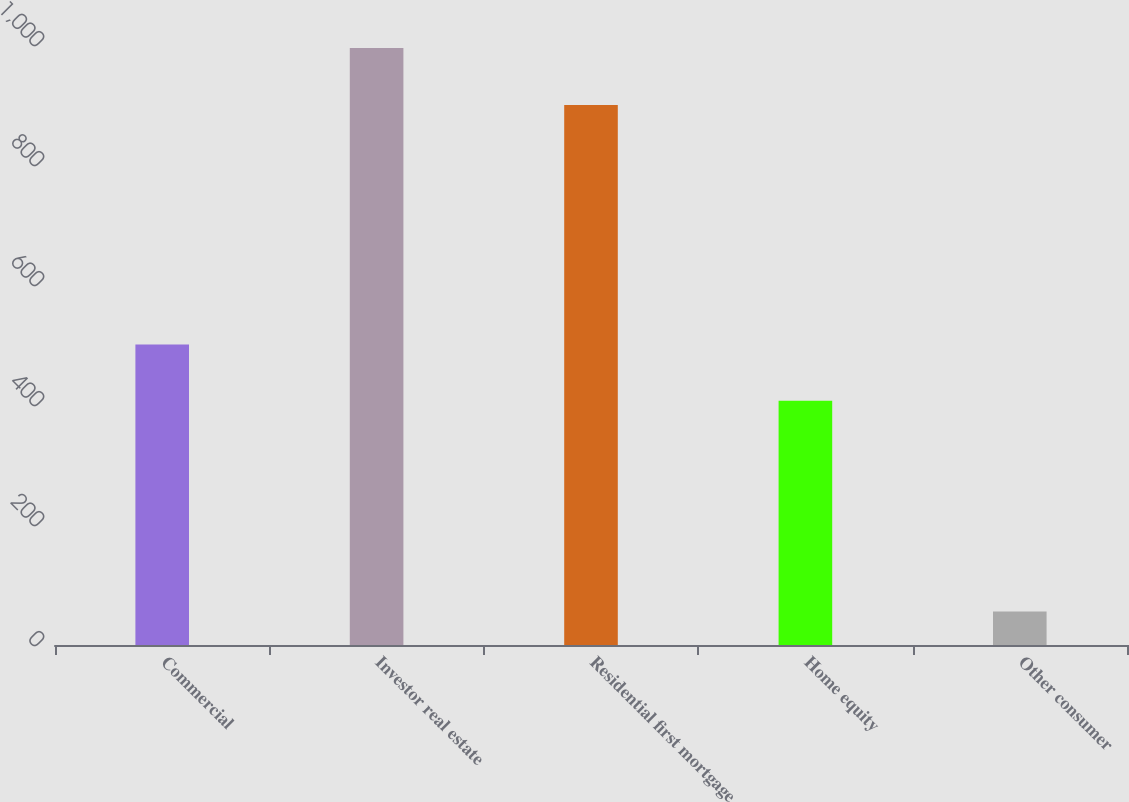Convert chart to OTSL. <chart><loc_0><loc_0><loc_500><loc_500><bar_chart><fcel>Commercial<fcel>Investor real estate<fcel>Residential first mortgage<fcel>Home equity<fcel>Other consumer<nl><fcel>500.9<fcel>995<fcel>900<fcel>407<fcel>56<nl></chart> 